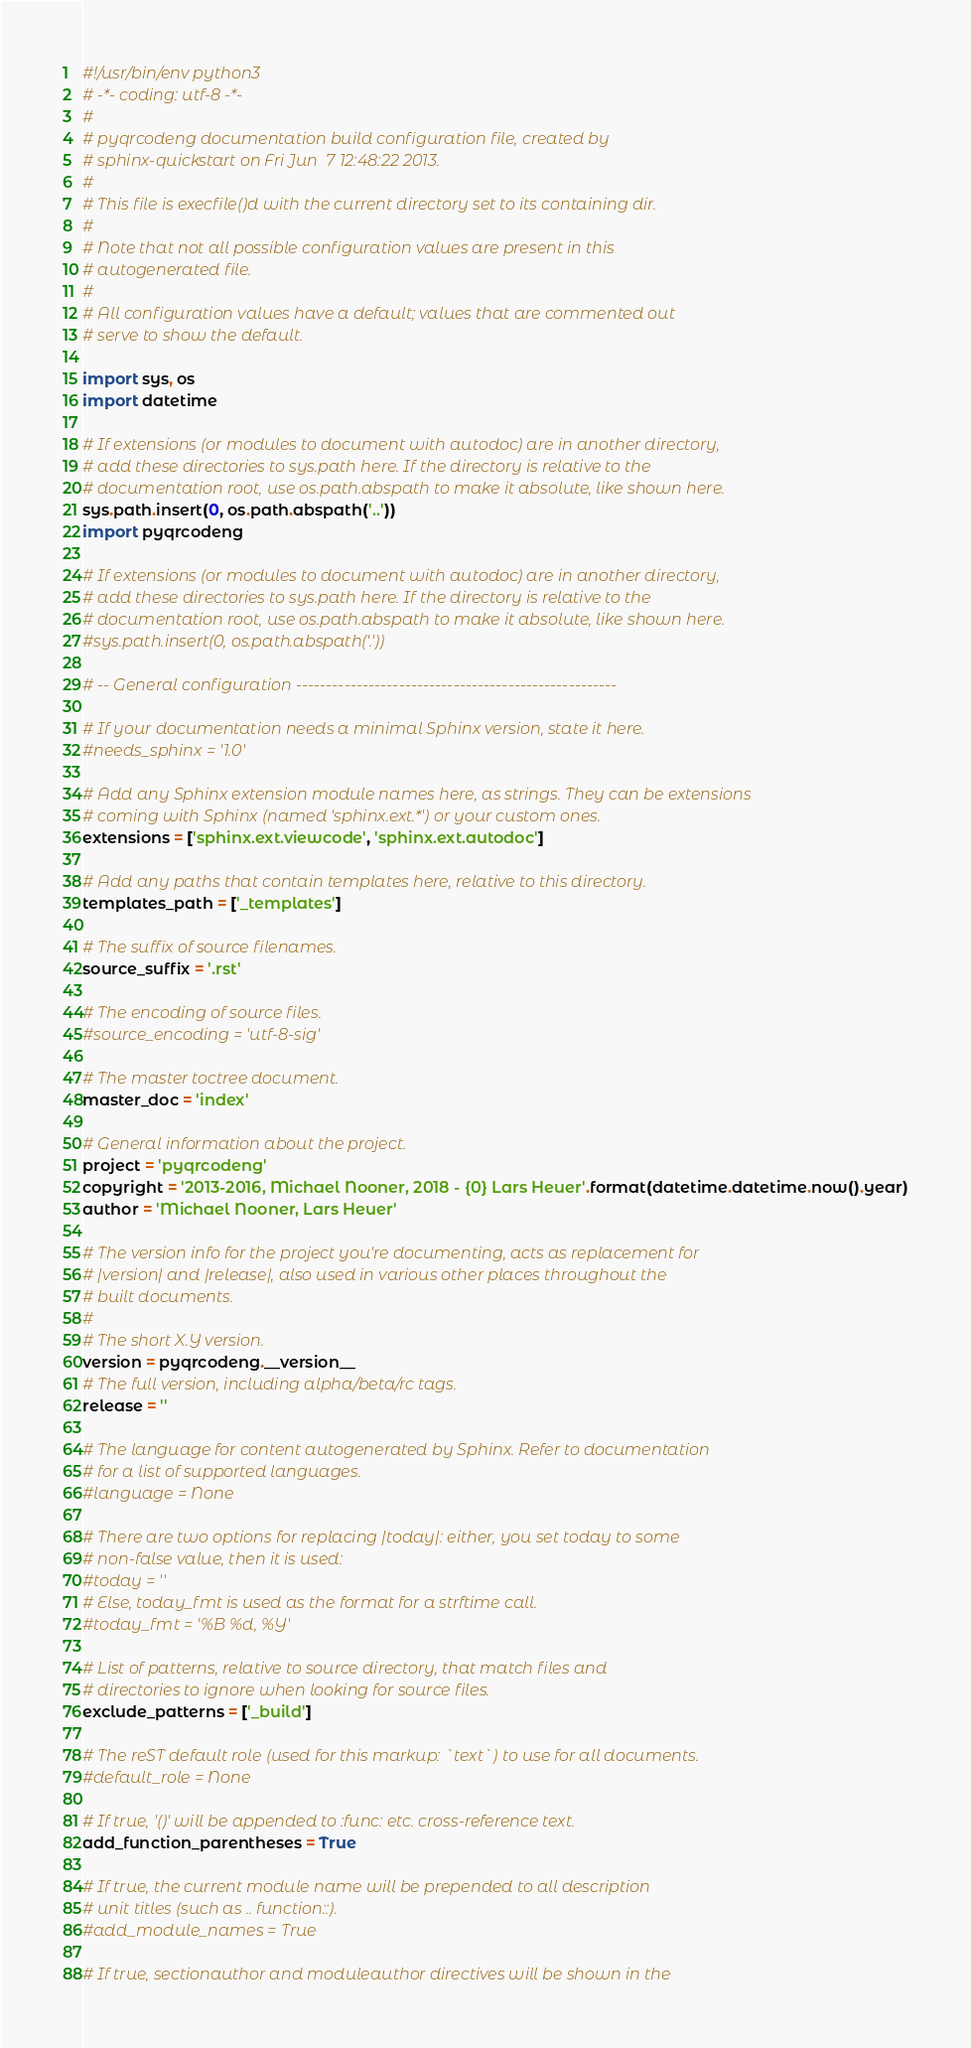<code> <loc_0><loc_0><loc_500><loc_500><_Python_>#!/usr/bin/env python3
# -*- coding: utf-8 -*-
#
# pyqrcodeng documentation build configuration file, created by
# sphinx-quickstart on Fri Jun  7 12:48:22 2013.
#
# This file is execfile()d with the current directory set to its containing dir.
#
# Note that not all possible configuration values are present in this
# autogenerated file.
#
# All configuration values have a default; values that are commented out
# serve to show the default.

import sys, os
import datetime

# If extensions (or modules to document with autodoc) are in another directory,
# add these directories to sys.path here. If the directory is relative to the
# documentation root, use os.path.abspath to make it absolute, like shown here.
sys.path.insert(0, os.path.abspath('..'))
import pyqrcodeng

# If extensions (or modules to document with autodoc) are in another directory,
# add these directories to sys.path here. If the directory is relative to the
# documentation root, use os.path.abspath to make it absolute, like shown here.
#sys.path.insert(0, os.path.abspath('.'))

# -- General configuration -----------------------------------------------------

# If your documentation needs a minimal Sphinx version, state it here.
#needs_sphinx = '1.0'

# Add any Sphinx extension module names here, as strings. They can be extensions
# coming with Sphinx (named 'sphinx.ext.*') or your custom ones.
extensions = ['sphinx.ext.viewcode', 'sphinx.ext.autodoc']

# Add any paths that contain templates here, relative to this directory.
templates_path = ['_templates']

# The suffix of source filenames.
source_suffix = '.rst'

# The encoding of source files.
#source_encoding = 'utf-8-sig'

# The master toctree document.
master_doc = 'index'

# General information about the project.
project = 'pyqrcodeng'
copyright = '2013-2016, Michael Nooner, 2018 - {0} Lars Heuer'.format(datetime.datetime.now().year)
author = 'Michael Nooner, Lars Heuer'

# The version info for the project you're documenting, acts as replacement for
# |version| and |release|, also used in various other places throughout the
# built documents.
#
# The short X.Y version.
version = pyqrcodeng.__version__
# The full version, including alpha/beta/rc tags.
release = ''

# The language for content autogenerated by Sphinx. Refer to documentation
# for a list of supported languages.
#language = None

# There are two options for replacing |today|: either, you set today to some
# non-false value, then it is used:
#today = ''
# Else, today_fmt is used as the format for a strftime call.
#today_fmt = '%B %d, %Y'

# List of patterns, relative to source directory, that match files and
# directories to ignore when looking for source files.
exclude_patterns = ['_build']

# The reST default role (used for this markup: `text`) to use for all documents.
#default_role = None

# If true, '()' will be appended to :func: etc. cross-reference text.
add_function_parentheses = True

# If true, the current module name will be prepended to all description
# unit titles (such as .. function::).
#add_module_names = True

# If true, sectionauthor and moduleauthor directives will be shown in the</code> 